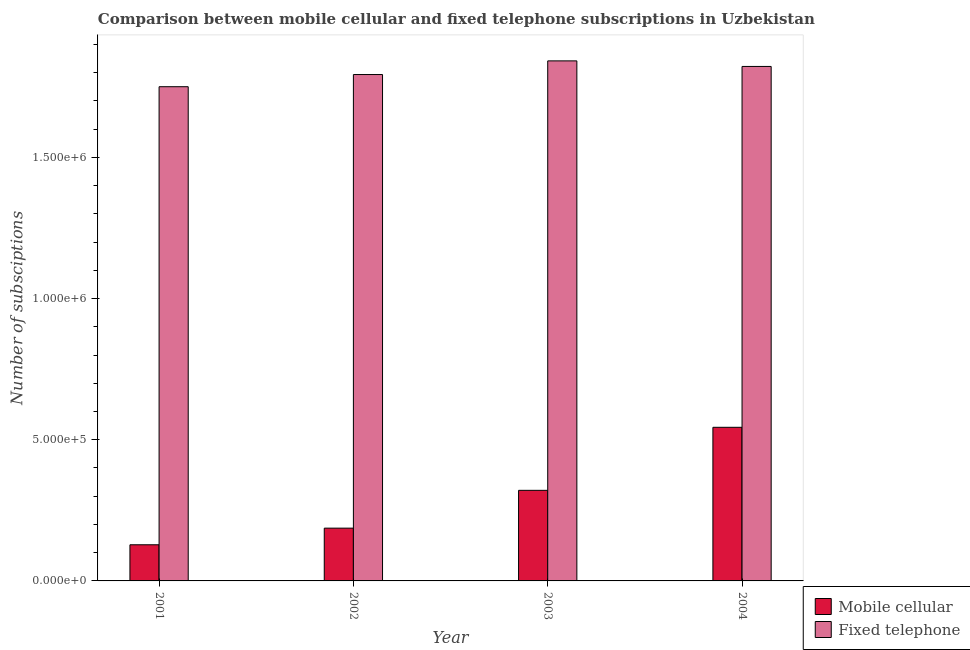How many different coloured bars are there?
Provide a succinct answer. 2. How many groups of bars are there?
Your answer should be compact. 4. Are the number of bars on each tick of the X-axis equal?
Your response must be concise. Yes. How many bars are there on the 3rd tick from the left?
Your answer should be very brief. 2. What is the label of the 3rd group of bars from the left?
Make the answer very short. 2003. What is the number of mobile cellular subscriptions in 2004?
Your answer should be very brief. 5.44e+05. Across all years, what is the maximum number of fixed telephone subscriptions?
Keep it short and to the point. 1.84e+06. Across all years, what is the minimum number of fixed telephone subscriptions?
Offer a very short reply. 1.75e+06. In which year was the number of fixed telephone subscriptions maximum?
Your answer should be very brief. 2003. In which year was the number of fixed telephone subscriptions minimum?
Keep it short and to the point. 2001. What is the total number of mobile cellular subscriptions in the graph?
Make the answer very short. 1.18e+06. What is the difference between the number of fixed telephone subscriptions in 2003 and that in 2004?
Your answer should be very brief. 1.97e+04. What is the difference between the number of mobile cellular subscriptions in 2001 and the number of fixed telephone subscriptions in 2002?
Keep it short and to the point. -5.89e+04. What is the average number of mobile cellular subscriptions per year?
Provide a short and direct response. 2.95e+05. In the year 2003, what is the difference between the number of fixed telephone subscriptions and number of mobile cellular subscriptions?
Your answer should be compact. 0. In how many years, is the number of fixed telephone subscriptions greater than 1300000?
Keep it short and to the point. 4. What is the ratio of the number of mobile cellular subscriptions in 2001 to that in 2003?
Give a very brief answer. 0.4. Is the number of mobile cellular subscriptions in 2001 less than that in 2004?
Ensure brevity in your answer.  Yes. What is the difference between the highest and the second highest number of mobile cellular subscriptions?
Provide a short and direct response. 2.23e+05. What is the difference between the highest and the lowest number of mobile cellular subscriptions?
Offer a very short reply. 4.16e+05. Is the sum of the number of mobile cellular subscriptions in 2002 and 2004 greater than the maximum number of fixed telephone subscriptions across all years?
Provide a succinct answer. Yes. What does the 2nd bar from the left in 2002 represents?
Your answer should be compact. Fixed telephone. What does the 2nd bar from the right in 2003 represents?
Offer a very short reply. Mobile cellular. How many bars are there?
Keep it short and to the point. 8. What is the difference between two consecutive major ticks on the Y-axis?
Provide a succinct answer. 5.00e+05. Does the graph contain grids?
Your response must be concise. No. Where does the legend appear in the graph?
Make the answer very short. Center right. How are the legend labels stacked?
Provide a succinct answer. Vertical. What is the title of the graph?
Offer a very short reply. Comparison between mobile cellular and fixed telephone subscriptions in Uzbekistan. What is the label or title of the Y-axis?
Your response must be concise. Number of subsciptions. What is the Number of subsciptions of Mobile cellular in 2001?
Provide a succinct answer. 1.28e+05. What is the Number of subsciptions of Fixed telephone in 2001?
Offer a very short reply. 1.75e+06. What is the Number of subsciptions of Mobile cellular in 2002?
Keep it short and to the point. 1.87e+05. What is the Number of subsciptions of Fixed telephone in 2002?
Ensure brevity in your answer.  1.79e+06. What is the Number of subsciptions of Mobile cellular in 2003?
Make the answer very short. 3.21e+05. What is the Number of subsciptions of Fixed telephone in 2003?
Offer a very short reply. 1.84e+06. What is the Number of subsciptions in Mobile cellular in 2004?
Make the answer very short. 5.44e+05. What is the Number of subsciptions in Fixed telephone in 2004?
Give a very brief answer. 1.82e+06. Across all years, what is the maximum Number of subsciptions of Mobile cellular?
Give a very brief answer. 5.44e+05. Across all years, what is the maximum Number of subsciptions in Fixed telephone?
Provide a succinct answer. 1.84e+06. Across all years, what is the minimum Number of subsciptions of Mobile cellular?
Offer a very short reply. 1.28e+05. Across all years, what is the minimum Number of subsciptions of Fixed telephone?
Offer a very short reply. 1.75e+06. What is the total Number of subsciptions of Mobile cellular in the graph?
Your answer should be compact. 1.18e+06. What is the total Number of subsciptions in Fixed telephone in the graph?
Ensure brevity in your answer.  7.21e+06. What is the difference between the Number of subsciptions of Mobile cellular in 2001 and that in 2002?
Offer a terse response. -5.89e+04. What is the difference between the Number of subsciptions in Fixed telephone in 2001 and that in 2002?
Your answer should be very brief. -4.31e+04. What is the difference between the Number of subsciptions of Mobile cellular in 2001 and that in 2003?
Provide a succinct answer. -1.93e+05. What is the difference between the Number of subsciptions in Fixed telephone in 2001 and that in 2003?
Keep it short and to the point. -9.15e+04. What is the difference between the Number of subsciptions in Mobile cellular in 2001 and that in 2004?
Ensure brevity in your answer.  -4.16e+05. What is the difference between the Number of subsciptions in Fixed telephone in 2001 and that in 2004?
Your answer should be compact. -7.17e+04. What is the difference between the Number of subsciptions of Mobile cellular in 2002 and that in 2003?
Offer a very short reply. -1.34e+05. What is the difference between the Number of subsciptions in Fixed telephone in 2002 and that in 2003?
Your answer should be very brief. -4.84e+04. What is the difference between the Number of subsciptions of Mobile cellular in 2002 and that in 2004?
Make the answer very short. -3.57e+05. What is the difference between the Number of subsciptions in Fixed telephone in 2002 and that in 2004?
Make the answer very short. -2.86e+04. What is the difference between the Number of subsciptions of Mobile cellular in 2003 and that in 2004?
Offer a very short reply. -2.23e+05. What is the difference between the Number of subsciptions in Fixed telephone in 2003 and that in 2004?
Your answer should be compact. 1.97e+04. What is the difference between the Number of subsciptions of Mobile cellular in 2001 and the Number of subsciptions of Fixed telephone in 2002?
Provide a succinct answer. -1.67e+06. What is the difference between the Number of subsciptions in Mobile cellular in 2001 and the Number of subsciptions in Fixed telephone in 2003?
Offer a very short reply. -1.71e+06. What is the difference between the Number of subsciptions in Mobile cellular in 2001 and the Number of subsciptions in Fixed telephone in 2004?
Make the answer very short. -1.69e+06. What is the difference between the Number of subsciptions of Mobile cellular in 2002 and the Number of subsciptions of Fixed telephone in 2003?
Offer a terse response. -1.65e+06. What is the difference between the Number of subsciptions in Mobile cellular in 2002 and the Number of subsciptions in Fixed telephone in 2004?
Ensure brevity in your answer.  -1.64e+06. What is the difference between the Number of subsciptions of Mobile cellular in 2003 and the Number of subsciptions of Fixed telephone in 2004?
Give a very brief answer. -1.50e+06. What is the average Number of subsciptions in Mobile cellular per year?
Your answer should be compact. 2.95e+05. What is the average Number of subsciptions of Fixed telephone per year?
Your answer should be very brief. 1.80e+06. In the year 2001, what is the difference between the Number of subsciptions of Mobile cellular and Number of subsciptions of Fixed telephone?
Keep it short and to the point. -1.62e+06. In the year 2002, what is the difference between the Number of subsciptions of Mobile cellular and Number of subsciptions of Fixed telephone?
Provide a short and direct response. -1.61e+06. In the year 2003, what is the difference between the Number of subsciptions in Mobile cellular and Number of subsciptions in Fixed telephone?
Give a very brief answer. -1.52e+06. In the year 2004, what is the difference between the Number of subsciptions of Mobile cellular and Number of subsciptions of Fixed telephone?
Make the answer very short. -1.28e+06. What is the ratio of the Number of subsciptions of Mobile cellular in 2001 to that in 2002?
Your response must be concise. 0.68. What is the ratio of the Number of subsciptions of Fixed telephone in 2001 to that in 2002?
Your answer should be compact. 0.98. What is the ratio of the Number of subsciptions in Mobile cellular in 2001 to that in 2003?
Offer a terse response. 0.4. What is the ratio of the Number of subsciptions of Fixed telephone in 2001 to that in 2003?
Keep it short and to the point. 0.95. What is the ratio of the Number of subsciptions of Mobile cellular in 2001 to that in 2004?
Offer a very short reply. 0.24. What is the ratio of the Number of subsciptions in Fixed telephone in 2001 to that in 2004?
Make the answer very short. 0.96. What is the ratio of the Number of subsciptions in Mobile cellular in 2002 to that in 2003?
Ensure brevity in your answer.  0.58. What is the ratio of the Number of subsciptions in Fixed telephone in 2002 to that in 2003?
Provide a short and direct response. 0.97. What is the ratio of the Number of subsciptions in Mobile cellular in 2002 to that in 2004?
Make the answer very short. 0.34. What is the ratio of the Number of subsciptions of Fixed telephone in 2002 to that in 2004?
Provide a succinct answer. 0.98. What is the ratio of the Number of subsciptions in Mobile cellular in 2003 to that in 2004?
Your answer should be very brief. 0.59. What is the ratio of the Number of subsciptions of Fixed telephone in 2003 to that in 2004?
Give a very brief answer. 1.01. What is the difference between the highest and the second highest Number of subsciptions in Mobile cellular?
Your response must be concise. 2.23e+05. What is the difference between the highest and the second highest Number of subsciptions of Fixed telephone?
Offer a very short reply. 1.97e+04. What is the difference between the highest and the lowest Number of subsciptions of Mobile cellular?
Make the answer very short. 4.16e+05. What is the difference between the highest and the lowest Number of subsciptions in Fixed telephone?
Make the answer very short. 9.15e+04. 